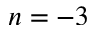<formula> <loc_0><loc_0><loc_500><loc_500>n = - 3</formula> 